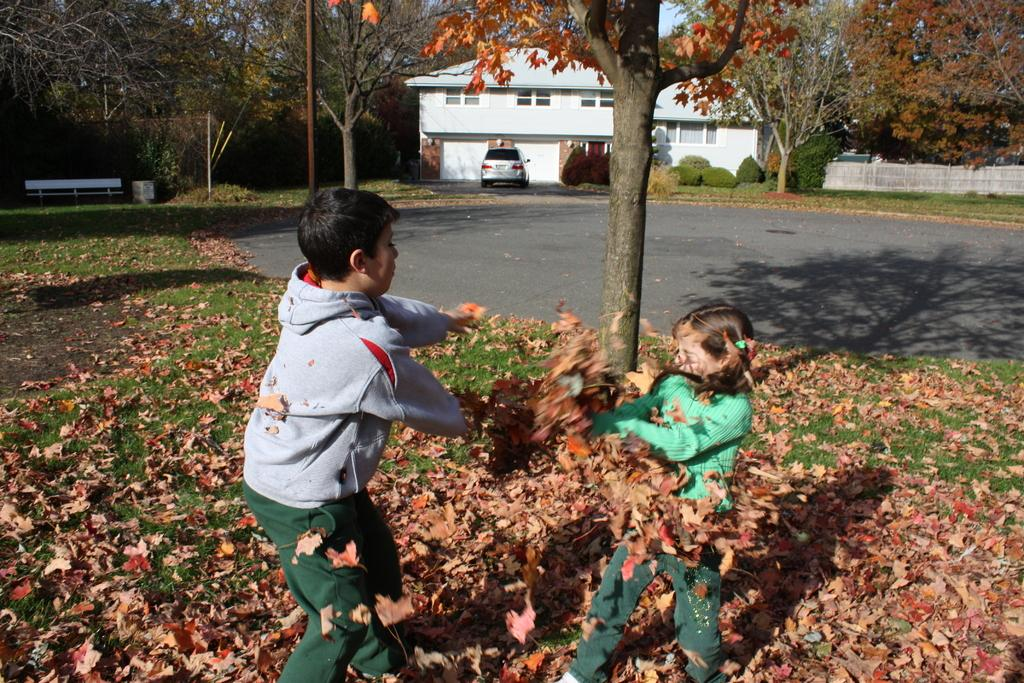How many children are present in the image? There are 2 children in the image. What are the children doing in the image? The children are playing with dry leaves. What type of vegetation can be seen in the image? There are trees in the image. What is the purpose of the pole in the image? The pole's purpose is not specified in the image, but it could be used for various purposes such as supporting a sign or a flag. Where is the bench located in the image? The bench is on the left side of the image. What structures can be seen in the background of the image? There is a building and a car in the background of the image. What color crayon is the child using to draw on the beds in the image? There are no crayons or beds present in the image; the children are playing with dry leaves. 